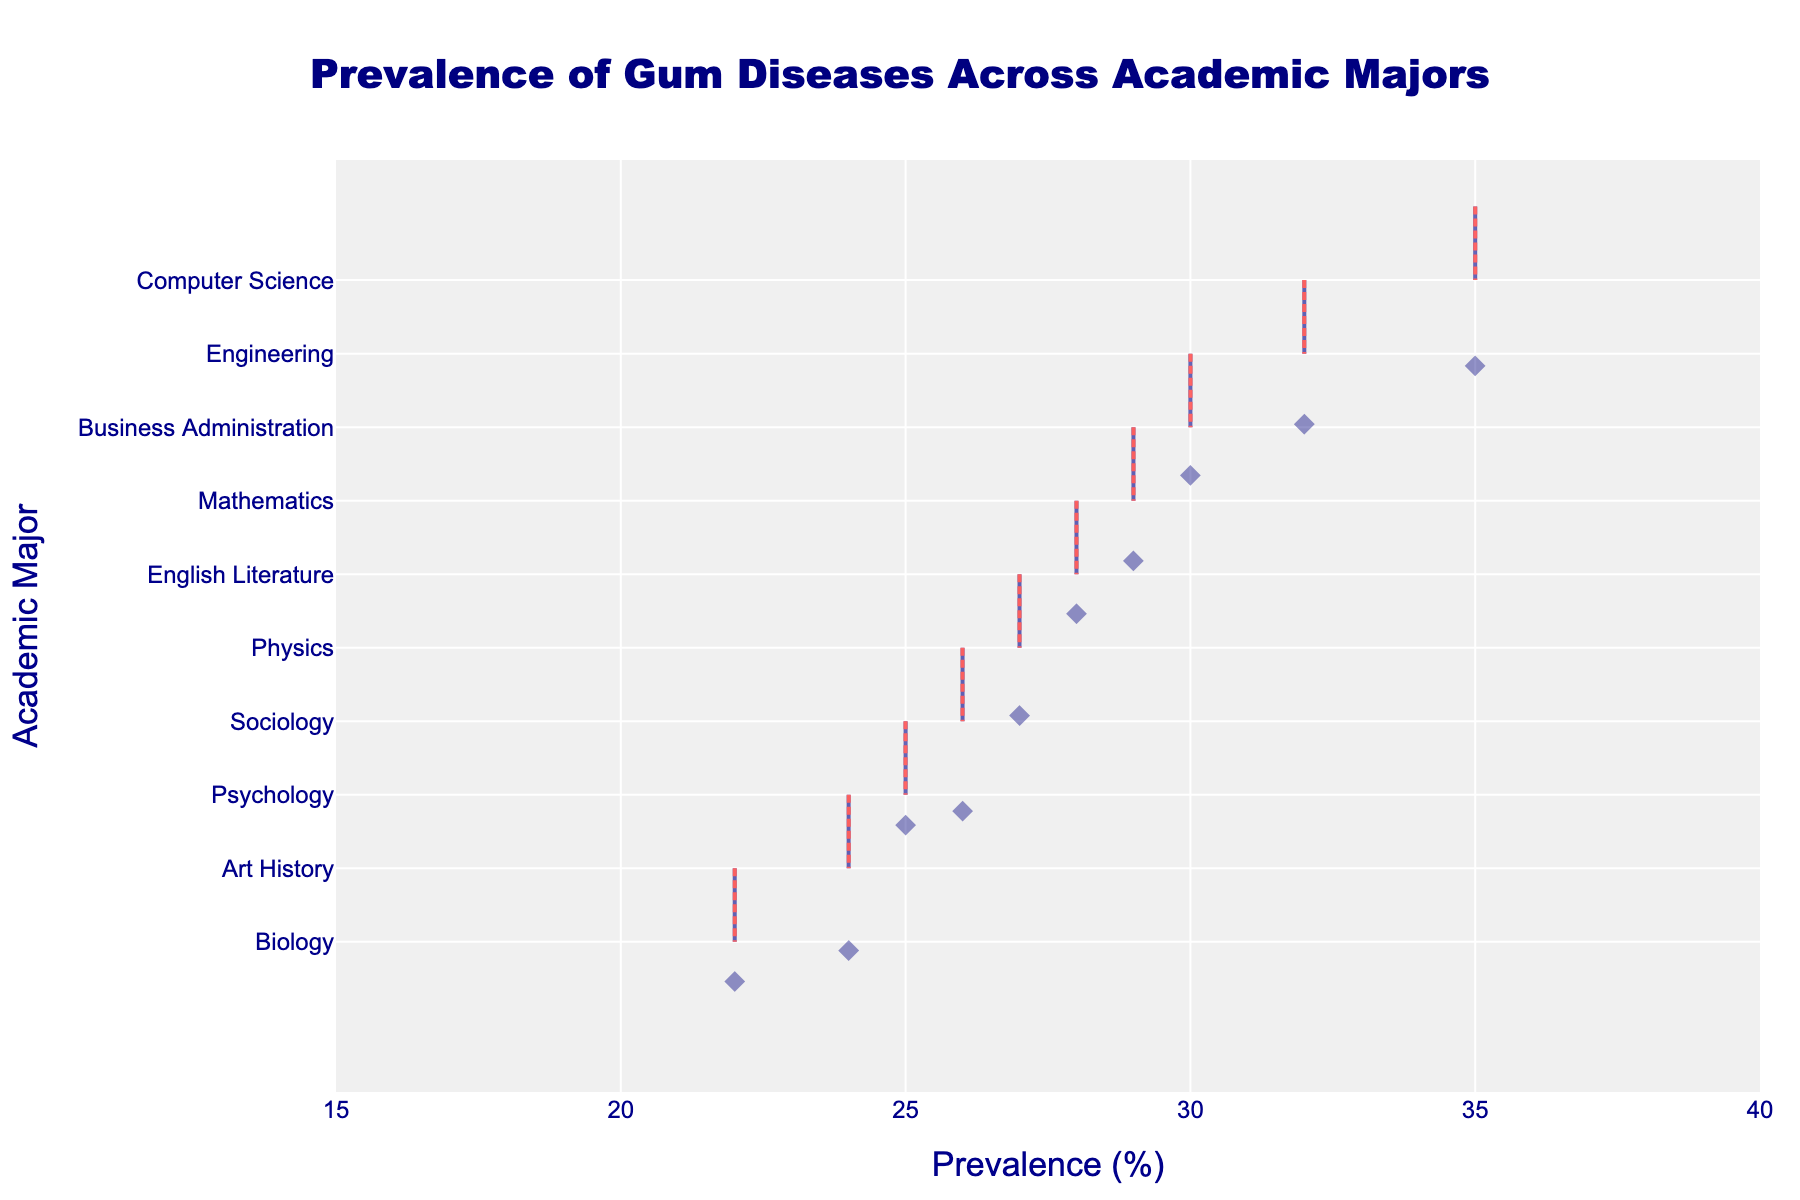Which major has the highest prevalence of gum diseases? The figure displays the prevalence of gum diseases across different academic majors with a horizontal density plot. By examining the distribution, the major with the highest prevalence is at the top of the plot.
Answer: Computer Science What is the prevalence of gum diseases in Psychology majors? Locate the Psychology major on the y-axis and follow the horizontal line to the x-axis, where the prevalence is marked.
Answer: 25% Which two majors have the closest prevalence rates of gum diseases? Examine the horizontal density plots and identify pairs of majors with similar x-axis values. The closest prevalence rates will appear nearly at the same value.
Answer: Physics and English Literature What's the average prevalence of gum diseases across all majors? Sum up the prevalence percentages for all majors: 35 (CS) + 28 (Eng Lit) + 22 (Bio) + 32 (Eng) + 25 (Psy) + 30 (BA) + 24 (AH) + 27 (Phy) + 26 (Soc) + 29 (Math) = 278. Divide by the number of majors, which is 10. So, the average is 278/10.
Answer: 27.8% Which major shows the least prevalence of gum diseases? Identify the major with the lowest value on the x-axis of the plot. This represents the least prevalence.
Answer: Biology Compare the prevalence of gum diseases between Business Administration and Mathematics. Which major has a higher prevalence? Identify the x-axis values for both majors and compare them. Business Administration has a prevalence of 30%, while Mathematics has 29%. Therefore, Business Administration has a higher prevalence.
Answer: Business Administration How many majors have a prevalence rate higher than 28%? Examine the density plot and count the number of majors with x-axis values greater than 28. These majors are Computer Science, Engineering, Business Administration, and Mathematics.
Answer: 4 What is the range of the prevalence of gum diseases across all majors? Find the difference between the maximum and minimum prevalence values. The maximum is 35% (Computer Science) and the minimum is 22% (Biology). So, the range is 35% - 22%.
Answer: 13% Does any major have a mean line different from the prevalence value itself? Look for visible deviations between the mean line (usually red) and the precise point values for each major. In this plot, since the mean line visible is typically tracing through the points' distribution, it generally confirms the individual points.
Answer: No 